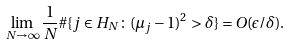<formula> <loc_0><loc_0><loc_500><loc_500>\lim _ { N \to \infty } \frac { 1 } { N } \# \{ j \in H _ { N } \colon ( \mu _ { j } - 1 ) ^ { 2 } > \delta \} = O ( \epsilon / \delta ) .</formula> 